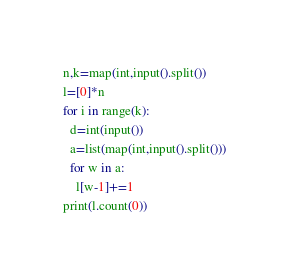<code> <loc_0><loc_0><loc_500><loc_500><_Python_>n,k=map(int,input().split())
l=[0]*n
for i in range(k):
  d=int(input())
  a=list(map(int,input().split()))
  for w in a:
    l[w-1]+=1
print(l.count(0))</code> 